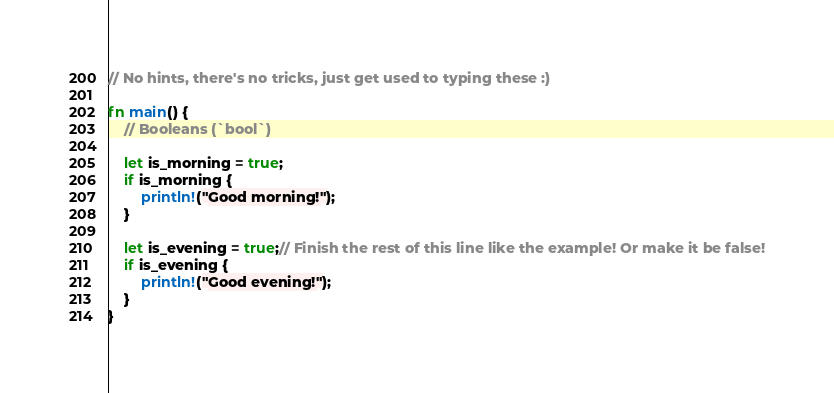Convert code to text. <code><loc_0><loc_0><loc_500><loc_500><_Rust_>// No hints, there's no tricks, just get used to typing these :)

fn main() {
    // Booleans (`bool`)

    let is_morning = true;
    if is_morning {
        println!("Good morning!");
    }

    let is_evening = true;// Finish the rest of this line like the example! Or make it be false!
    if is_evening {
        println!("Good evening!");
    }
}
</code> 